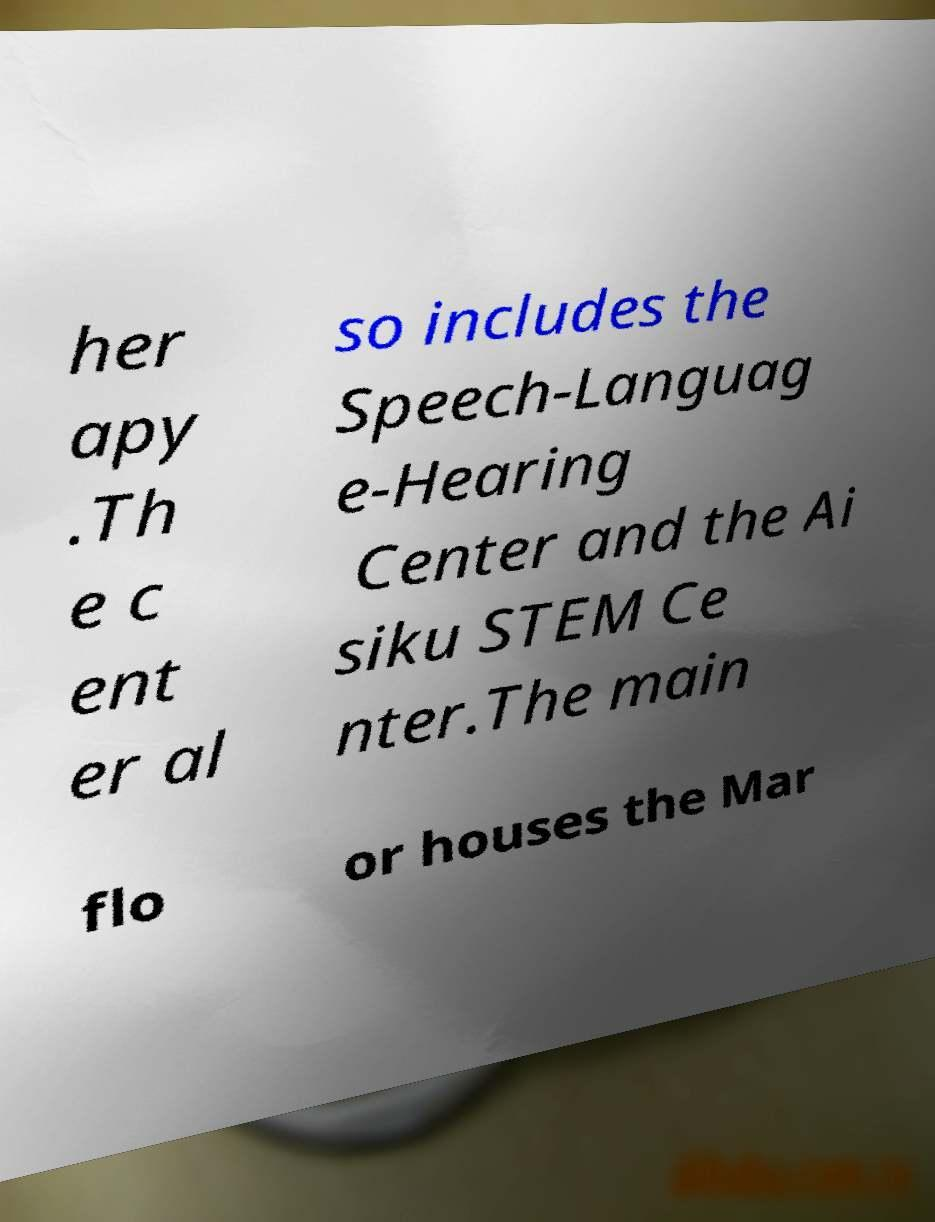Please read and relay the text visible in this image. What does it say? her apy .Th e c ent er al so includes the Speech-Languag e-Hearing Center and the Ai siku STEM Ce nter.The main flo or houses the Mar 